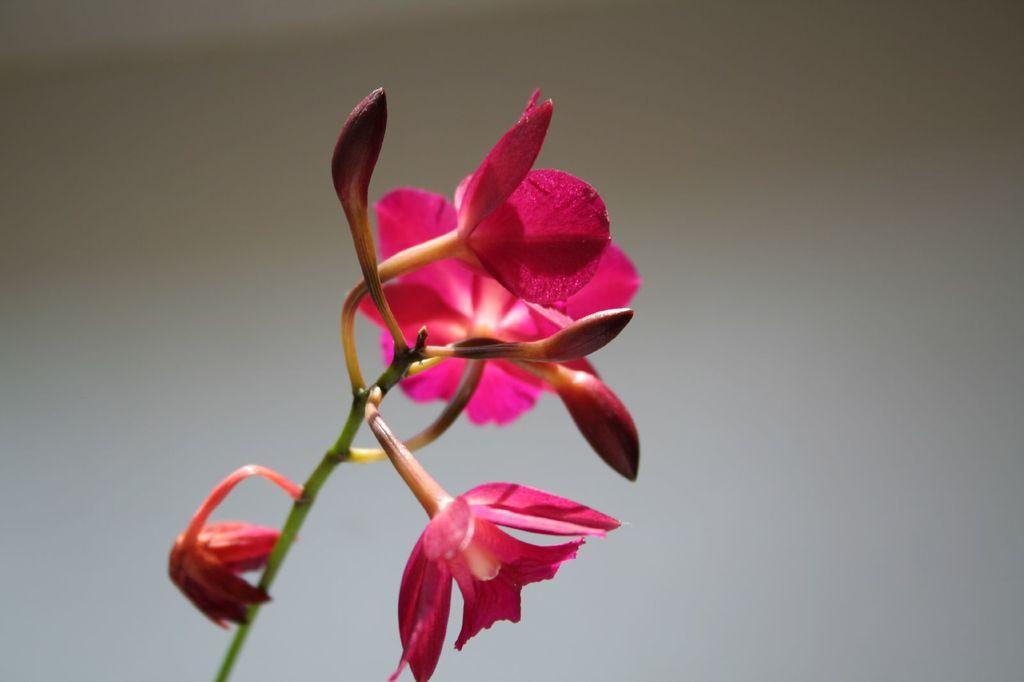Describe this image in one or two sentences. In this picture we can see flowers and buds to the stem. Behind the flowers there is a blurred background. 